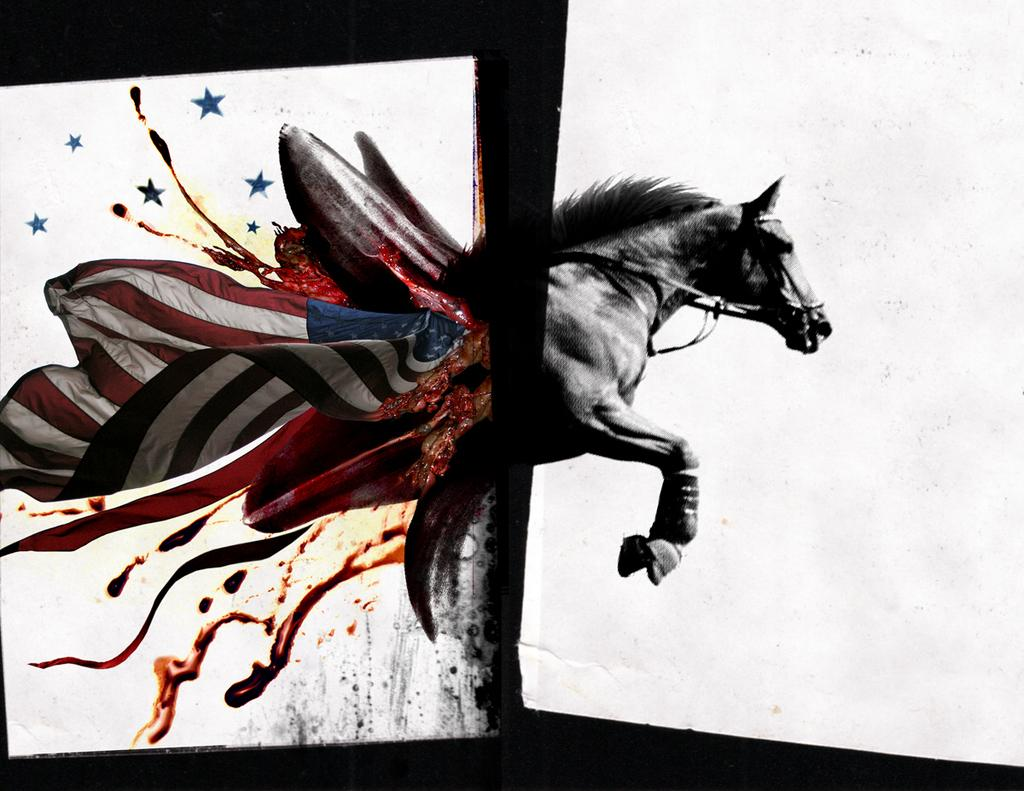What is the main subject of the painting in the image? There is a painting of a horse in the image. What type of guitar is being played by the horse in the image? There is no guitar present in the image, as it only features a painting of a horse. 